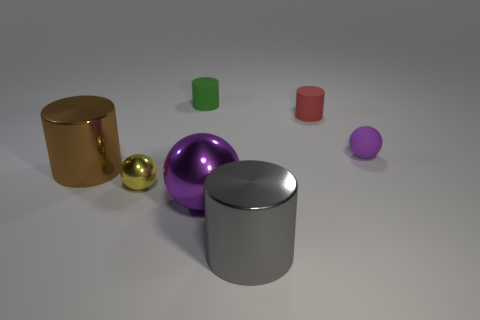What material do the objects appear to be made of? The objects in the image exhibit varying finishes and reflections suggesting they are likely made of different materials, such as matte or gloss painted metals, giving each a unique texture and visual appeal. 